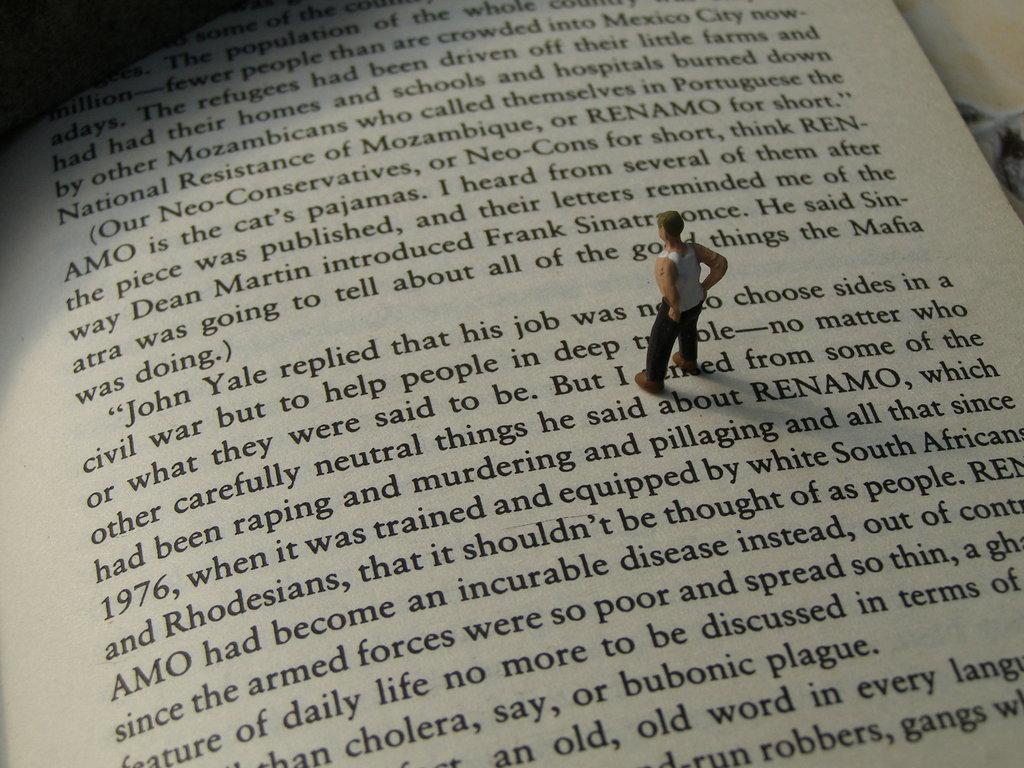<image>
Provide a brief description of the given image. A book with a little toy man reading about John Yale. 